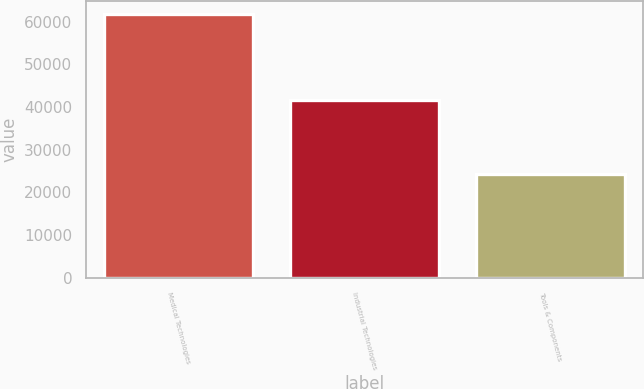Convert chart. <chart><loc_0><loc_0><loc_500><loc_500><bar_chart><fcel>Medical Technologies<fcel>Industrial Technologies<fcel>Tools & Components<nl><fcel>61725<fcel>41548<fcel>24375<nl></chart> 